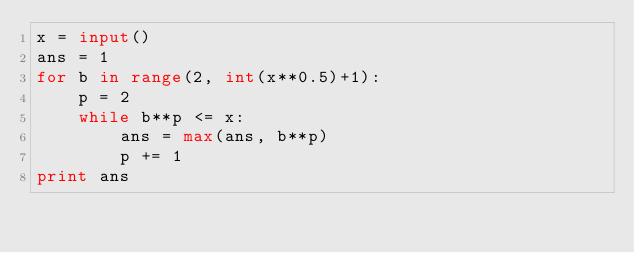<code> <loc_0><loc_0><loc_500><loc_500><_Python_>x = input()
ans = 1
for b in range(2, int(x**0.5)+1):
    p = 2
    while b**p <= x:
        ans = max(ans, b**p)
        p += 1
print ans</code> 